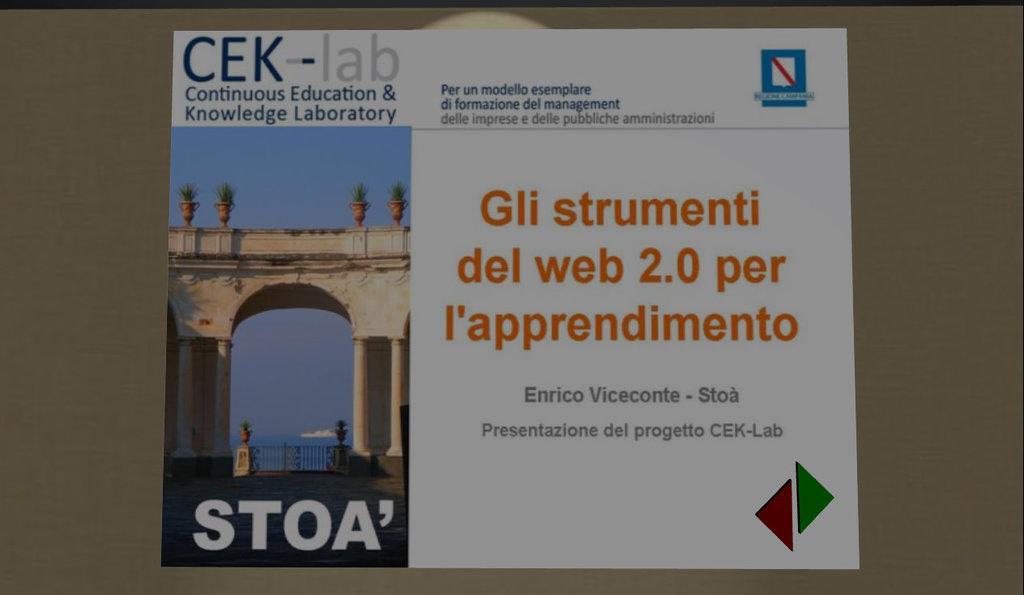Provide a one-sentence caption for the provided image. A white postcard with Continuous Education and Knowledge Laboratory on it. 